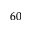Convert formula to latex. <formula><loc_0><loc_0><loc_500><loc_500>^ { 6 0 }</formula> 